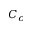<formula> <loc_0><loc_0><loc_500><loc_500>C _ { c }</formula> 